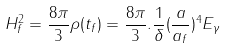Convert formula to latex. <formula><loc_0><loc_0><loc_500><loc_500>H _ { f } ^ { 2 } = \frac { 8 \pi } { 3 } \rho ( t _ { f } ) = \frac { 8 \pi } { 3 } . \frac { 1 } { \delta } ( \frac { a } { a _ { f } } ) ^ { 4 } E _ { \gamma }</formula> 